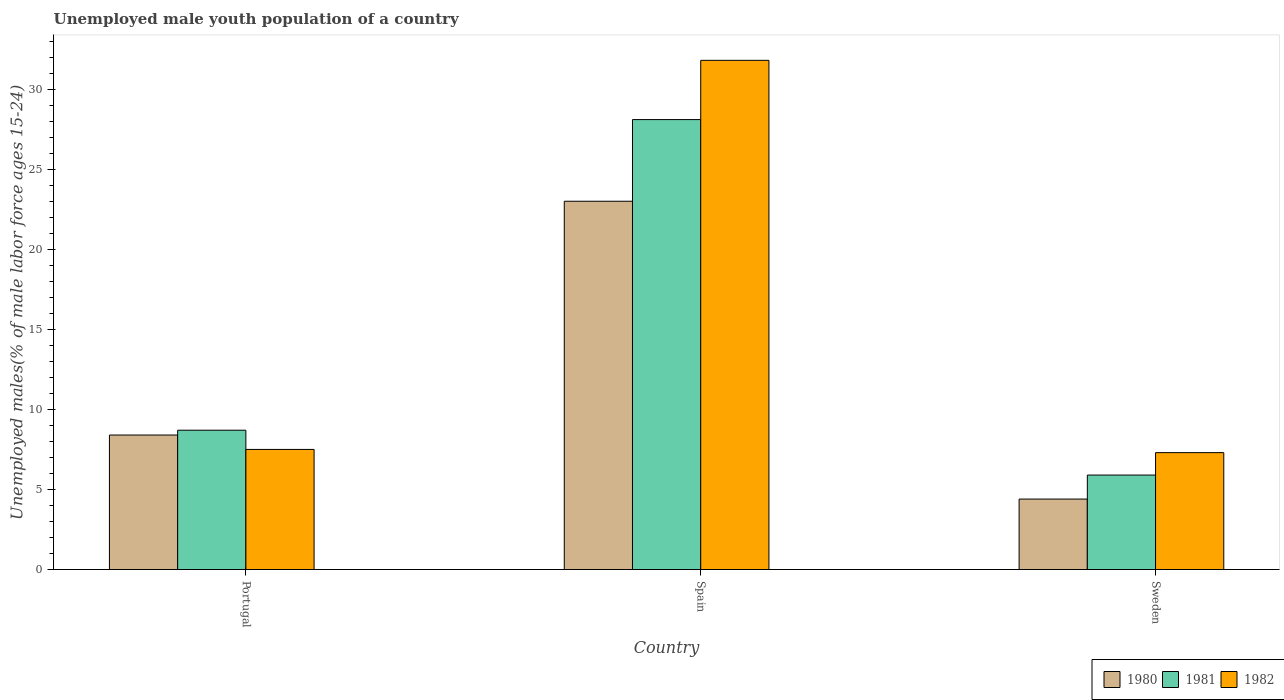How many different coloured bars are there?
Offer a terse response. 3. Are the number of bars per tick equal to the number of legend labels?
Provide a short and direct response. Yes. How many bars are there on the 3rd tick from the left?
Provide a short and direct response. 3. How many bars are there on the 3rd tick from the right?
Keep it short and to the point. 3. In how many cases, is the number of bars for a given country not equal to the number of legend labels?
Offer a terse response. 0. What is the percentage of unemployed male youth population in 1981 in Portugal?
Keep it short and to the point. 8.7. Across all countries, what is the maximum percentage of unemployed male youth population in 1981?
Your answer should be compact. 28.1. Across all countries, what is the minimum percentage of unemployed male youth population in 1982?
Provide a short and direct response. 7.3. In which country was the percentage of unemployed male youth population in 1980 minimum?
Keep it short and to the point. Sweden. What is the total percentage of unemployed male youth population in 1980 in the graph?
Ensure brevity in your answer.  35.8. What is the difference between the percentage of unemployed male youth population in 1980 in Portugal and that in Sweden?
Make the answer very short. 4. What is the difference between the percentage of unemployed male youth population in 1980 in Spain and the percentage of unemployed male youth population in 1982 in Portugal?
Offer a very short reply. 15.5. What is the average percentage of unemployed male youth population in 1981 per country?
Your answer should be compact. 14.23. What is the difference between the percentage of unemployed male youth population of/in 1980 and percentage of unemployed male youth population of/in 1982 in Sweden?
Provide a short and direct response. -2.9. In how many countries, is the percentage of unemployed male youth population in 1980 greater than 29 %?
Offer a very short reply. 0. What is the ratio of the percentage of unemployed male youth population in 1982 in Portugal to that in Sweden?
Your answer should be compact. 1.03. Is the percentage of unemployed male youth population in 1981 in Portugal less than that in Spain?
Offer a very short reply. Yes. Is the difference between the percentage of unemployed male youth population in 1980 in Portugal and Sweden greater than the difference between the percentage of unemployed male youth population in 1982 in Portugal and Sweden?
Your answer should be compact. Yes. What is the difference between the highest and the second highest percentage of unemployed male youth population in 1982?
Offer a terse response. -0.2. What is the difference between the highest and the lowest percentage of unemployed male youth population in 1980?
Your response must be concise. 18.6. Is it the case that in every country, the sum of the percentage of unemployed male youth population in 1982 and percentage of unemployed male youth population in 1980 is greater than the percentage of unemployed male youth population in 1981?
Your answer should be compact. Yes. How many bars are there?
Offer a terse response. 9. How many countries are there in the graph?
Your response must be concise. 3. What is the difference between two consecutive major ticks on the Y-axis?
Provide a succinct answer. 5. Are the values on the major ticks of Y-axis written in scientific E-notation?
Provide a short and direct response. No. Does the graph contain any zero values?
Ensure brevity in your answer.  No. Does the graph contain grids?
Give a very brief answer. No. How are the legend labels stacked?
Provide a succinct answer. Horizontal. What is the title of the graph?
Provide a short and direct response. Unemployed male youth population of a country. Does "2002" appear as one of the legend labels in the graph?
Ensure brevity in your answer.  No. What is the label or title of the Y-axis?
Provide a succinct answer. Unemployed males(% of male labor force ages 15-24). What is the Unemployed males(% of male labor force ages 15-24) in 1980 in Portugal?
Provide a succinct answer. 8.4. What is the Unemployed males(% of male labor force ages 15-24) in 1981 in Portugal?
Your answer should be compact. 8.7. What is the Unemployed males(% of male labor force ages 15-24) in 1982 in Portugal?
Offer a very short reply. 7.5. What is the Unemployed males(% of male labor force ages 15-24) of 1980 in Spain?
Make the answer very short. 23. What is the Unemployed males(% of male labor force ages 15-24) of 1981 in Spain?
Make the answer very short. 28.1. What is the Unemployed males(% of male labor force ages 15-24) in 1982 in Spain?
Your answer should be very brief. 31.8. What is the Unemployed males(% of male labor force ages 15-24) in 1980 in Sweden?
Your answer should be compact. 4.4. What is the Unemployed males(% of male labor force ages 15-24) in 1981 in Sweden?
Make the answer very short. 5.9. What is the Unemployed males(% of male labor force ages 15-24) in 1982 in Sweden?
Provide a short and direct response. 7.3. Across all countries, what is the maximum Unemployed males(% of male labor force ages 15-24) in 1980?
Provide a short and direct response. 23. Across all countries, what is the maximum Unemployed males(% of male labor force ages 15-24) of 1981?
Your response must be concise. 28.1. Across all countries, what is the maximum Unemployed males(% of male labor force ages 15-24) in 1982?
Give a very brief answer. 31.8. Across all countries, what is the minimum Unemployed males(% of male labor force ages 15-24) in 1980?
Your answer should be compact. 4.4. Across all countries, what is the minimum Unemployed males(% of male labor force ages 15-24) in 1981?
Your response must be concise. 5.9. Across all countries, what is the minimum Unemployed males(% of male labor force ages 15-24) in 1982?
Ensure brevity in your answer.  7.3. What is the total Unemployed males(% of male labor force ages 15-24) of 1980 in the graph?
Offer a very short reply. 35.8. What is the total Unemployed males(% of male labor force ages 15-24) of 1981 in the graph?
Your answer should be very brief. 42.7. What is the total Unemployed males(% of male labor force ages 15-24) in 1982 in the graph?
Make the answer very short. 46.6. What is the difference between the Unemployed males(% of male labor force ages 15-24) in 1980 in Portugal and that in Spain?
Your answer should be compact. -14.6. What is the difference between the Unemployed males(% of male labor force ages 15-24) in 1981 in Portugal and that in Spain?
Your answer should be compact. -19.4. What is the difference between the Unemployed males(% of male labor force ages 15-24) in 1982 in Portugal and that in Spain?
Offer a very short reply. -24.3. What is the difference between the Unemployed males(% of male labor force ages 15-24) of 1980 in Portugal and that in Sweden?
Give a very brief answer. 4. What is the difference between the Unemployed males(% of male labor force ages 15-24) of 1981 in Portugal and that in Sweden?
Offer a very short reply. 2.8. What is the difference between the Unemployed males(% of male labor force ages 15-24) in 1980 in Spain and that in Sweden?
Provide a succinct answer. 18.6. What is the difference between the Unemployed males(% of male labor force ages 15-24) in 1981 in Spain and that in Sweden?
Offer a very short reply. 22.2. What is the difference between the Unemployed males(% of male labor force ages 15-24) in 1982 in Spain and that in Sweden?
Offer a very short reply. 24.5. What is the difference between the Unemployed males(% of male labor force ages 15-24) in 1980 in Portugal and the Unemployed males(% of male labor force ages 15-24) in 1981 in Spain?
Provide a short and direct response. -19.7. What is the difference between the Unemployed males(% of male labor force ages 15-24) of 1980 in Portugal and the Unemployed males(% of male labor force ages 15-24) of 1982 in Spain?
Give a very brief answer. -23.4. What is the difference between the Unemployed males(% of male labor force ages 15-24) of 1981 in Portugal and the Unemployed males(% of male labor force ages 15-24) of 1982 in Spain?
Offer a terse response. -23.1. What is the difference between the Unemployed males(% of male labor force ages 15-24) in 1980 in Portugal and the Unemployed males(% of male labor force ages 15-24) in 1981 in Sweden?
Keep it short and to the point. 2.5. What is the difference between the Unemployed males(% of male labor force ages 15-24) of 1980 in Portugal and the Unemployed males(% of male labor force ages 15-24) of 1982 in Sweden?
Offer a terse response. 1.1. What is the difference between the Unemployed males(% of male labor force ages 15-24) of 1981 in Portugal and the Unemployed males(% of male labor force ages 15-24) of 1982 in Sweden?
Make the answer very short. 1.4. What is the difference between the Unemployed males(% of male labor force ages 15-24) in 1980 in Spain and the Unemployed males(% of male labor force ages 15-24) in 1982 in Sweden?
Ensure brevity in your answer.  15.7. What is the difference between the Unemployed males(% of male labor force ages 15-24) of 1981 in Spain and the Unemployed males(% of male labor force ages 15-24) of 1982 in Sweden?
Offer a terse response. 20.8. What is the average Unemployed males(% of male labor force ages 15-24) in 1980 per country?
Offer a very short reply. 11.93. What is the average Unemployed males(% of male labor force ages 15-24) of 1981 per country?
Make the answer very short. 14.23. What is the average Unemployed males(% of male labor force ages 15-24) of 1982 per country?
Your answer should be very brief. 15.53. What is the difference between the Unemployed males(% of male labor force ages 15-24) of 1980 and Unemployed males(% of male labor force ages 15-24) of 1981 in Portugal?
Your answer should be very brief. -0.3. What is the difference between the Unemployed males(% of male labor force ages 15-24) of 1980 and Unemployed males(% of male labor force ages 15-24) of 1982 in Portugal?
Provide a succinct answer. 0.9. What is the difference between the Unemployed males(% of male labor force ages 15-24) of 1981 and Unemployed males(% of male labor force ages 15-24) of 1982 in Portugal?
Offer a very short reply. 1.2. What is the difference between the Unemployed males(% of male labor force ages 15-24) in 1981 and Unemployed males(% of male labor force ages 15-24) in 1982 in Spain?
Offer a terse response. -3.7. What is the difference between the Unemployed males(% of male labor force ages 15-24) of 1980 and Unemployed males(% of male labor force ages 15-24) of 1981 in Sweden?
Offer a very short reply. -1.5. What is the difference between the Unemployed males(% of male labor force ages 15-24) of 1981 and Unemployed males(% of male labor force ages 15-24) of 1982 in Sweden?
Keep it short and to the point. -1.4. What is the ratio of the Unemployed males(% of male labor force ages 15-24) in 1980 in Portugal to that in Spain?
Your answer should be very brief. 0.37. What is the ratio of the Unemployed males(% of male labor force ages 15-24) in 1981 in Portugal to that in Spain?
Make the answer very short. 0.31. What is the ratio of the Unemployed males(% of male labor force ages 15-24) in 1982 in Portugal to that in Spain?
Provide a succinct answer. 0.24. What is the ratio of the Unemployed males(% of male labor force ages 15-24) in 1980 in Portugal to that in Sweden?
Provide a short and direct response. 1.91. What is the ratio of the Unemployed males(% of male labor force ages 15-24) of 1981 in Portugal to that in Sweden?
Provide a short and direct response. 1.47. What is the ratio of the Unemployed males(% of male labor force ages 15-24) in 1982 in Portugal to that in Sweden?
Your response must be concise. 1.03. What is the ratio of the Unemployed males(% of male labor force ages 15-24) of 1980 in Spain to that in Sweden?
Provide a short and direct response. 5.23. What is the ratio of the Unemployed males(% of male labor force ages 15-24) of 1981 in Spain to that in Sweden?
Offer a terse response. 4.76. What is the ratio of the Unemployed males(% of male labor force ages 15-24) in 1982 in Spain to that in Sweden?
Keep it short and to the point. 4.36. What is the difference between the highest and the second highest Unemployed males(% of male labor force ages 15-24) of 1981?
Offer a terse response. 19.4. What is the difference between the highest and the second highest Unemployed males(% of male labor force ages 15-24) of 1982?
Offer a very short reply. 24.3. What is the difference between the highest and the lowest Unemployed males(% of male labor force ages 15-24) of 1980?
Ensure brevity in your answer.  18.6. What is the difference between the highest and the lowest Unemployed males(% of male labor force ages 15-24) in 1982?
Your answer should be very brief. 24.5. 